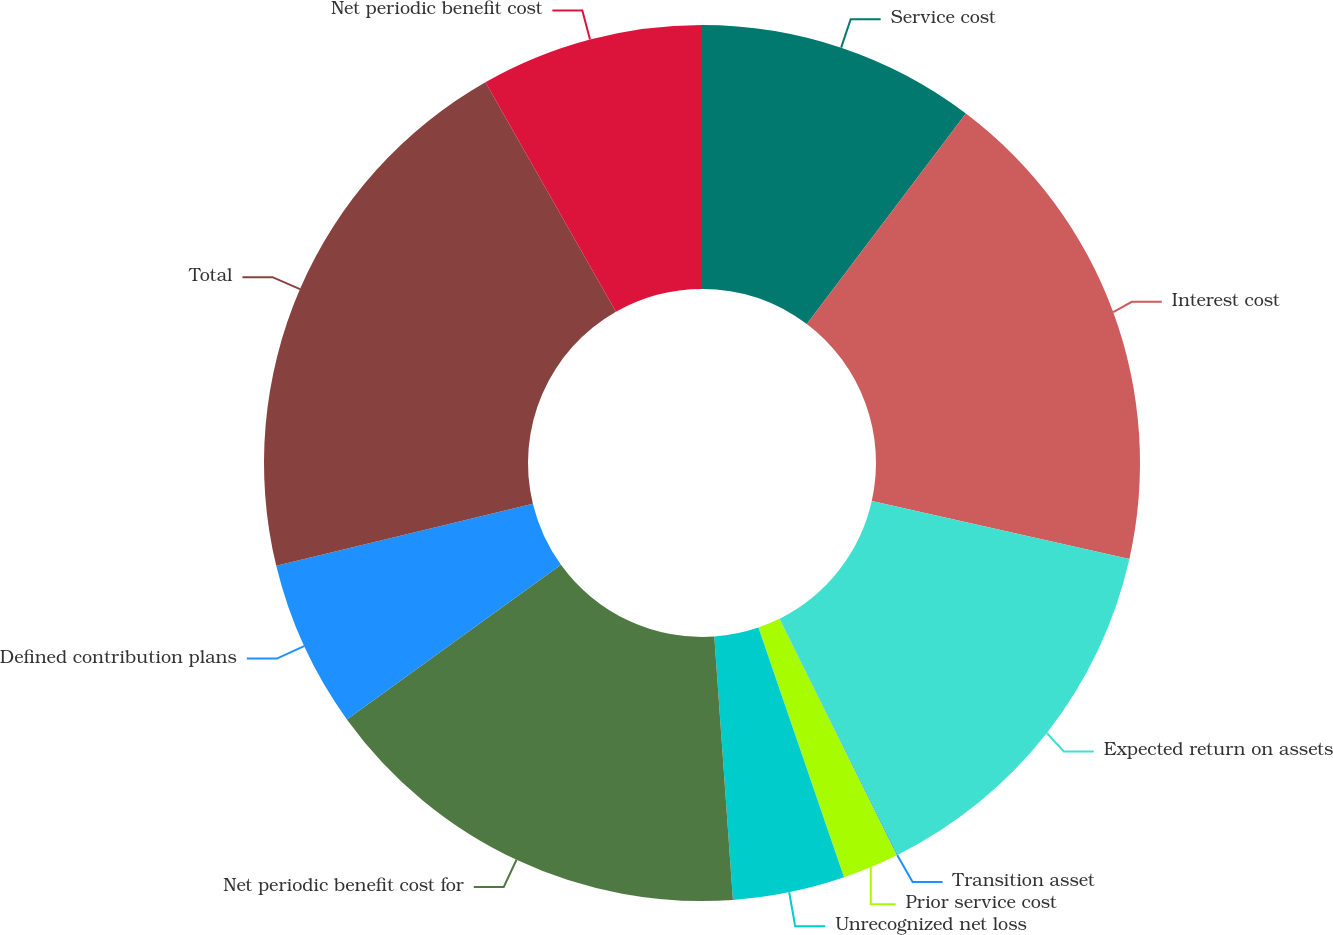<chart> <loc_0><loc_0><loc_500><loc_500><pie_chart><fcel>Service cost<fcel>Interest cost<fcel>Expected return on assets<fcel>Transition asset<fcel>Prior service cost<fcel>Unrecognized net loss<fcel>Net periodic benefit cost for<fcel>Defined contribution plans<fcel>Total<fcel>Net periodic benefit cost<nl><fcel>10.29%<fcel>18.22%<fcel>14.12%<fcel>0.03%<fcel>2.08%<fcel>4.13%<fcel>16.17%<fcel>6.18%<fcel>20.54%<fcel>8.23%<nl></chart> 